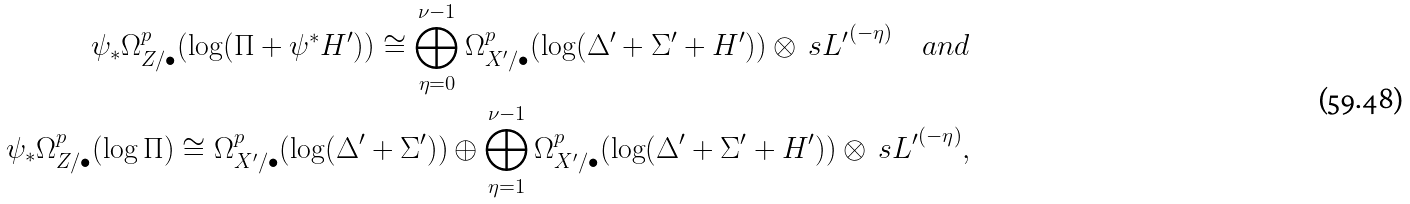<formula> <loc_0><loc_0><loc_500><loc_500>\psi _ { * } \Omega ^ { p } _ { Z / \bullet } ( \log ( \Pi + \psi ^ { * } H ^ { \prime } ) ) \cong \bigoplus _ { \eta = 0 } ^ { \nu - 1 } \Omega ^ { p } _ { X ^ { \prime } / \bullet } ( \log ( \Delta ^ { \prime } + \Sigma ^ { \prime } + H ^ { \prime } ) ) \otimes { \ s L ^ { \prime } } ^ { ( - \eta ) } \quad a n d \\ \psi _ { * } \Omega ^ { p } _ { Z / \bullet } ( \log \Pi ) \cong \Omega ^ { p } _ { X ^ { \prime } / \bullet } ( \log ( \Delta ^ { \prime } + \Sigma ^ { \prime } ) ) \oplus \bigoplus _ { \eta = 1 } ^ { \nu - 1 } \Omega ^ { p } _ { X ^ { \prime } / \bullet } ( \log ( \Delta ^ { \prime } + \Sigma ^ { \prime } + H ^ { \prime } ) ) \otimes { \ s L ^ { \prime } } ^ { ( - \eta ) } ,</formula> 